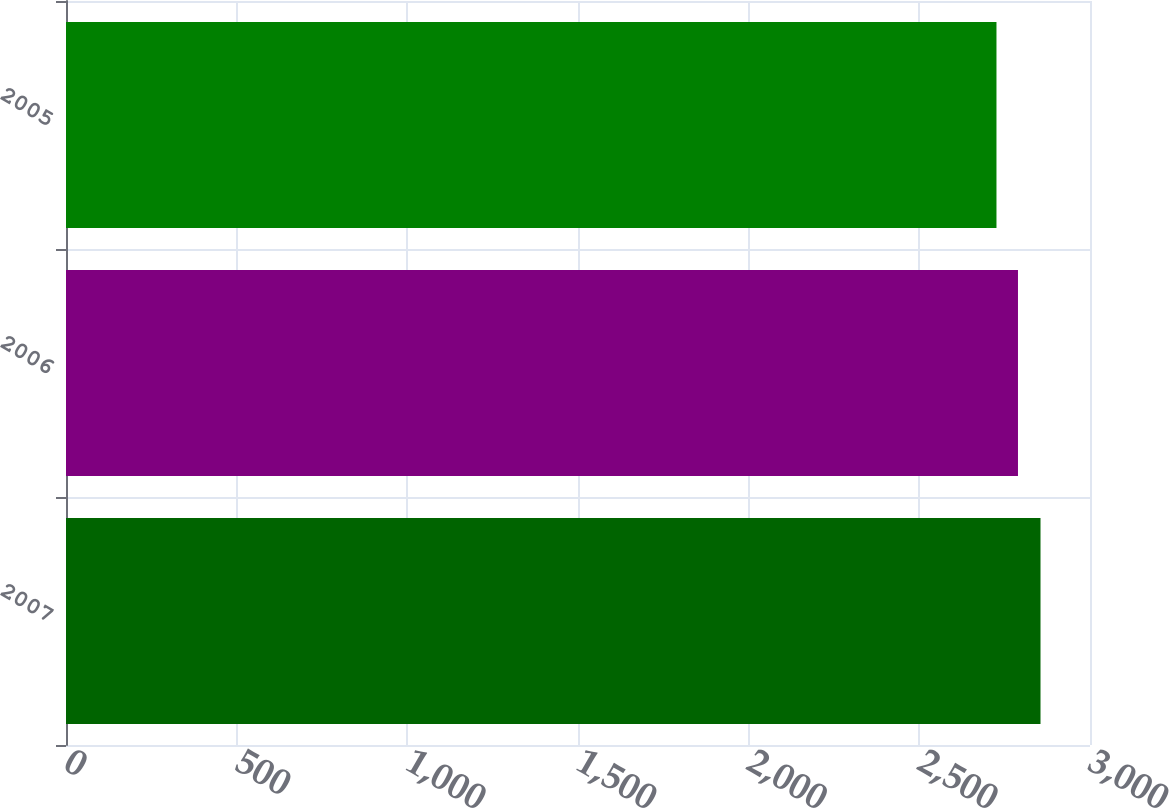<chart> <loc_0><loc_0><loc_500><loc_500><bar_chart><fcel>2007<fcel>2006<fcel>2005<nl><fcel>2855<fcel>2789<fcel>2726<nl></chart> 